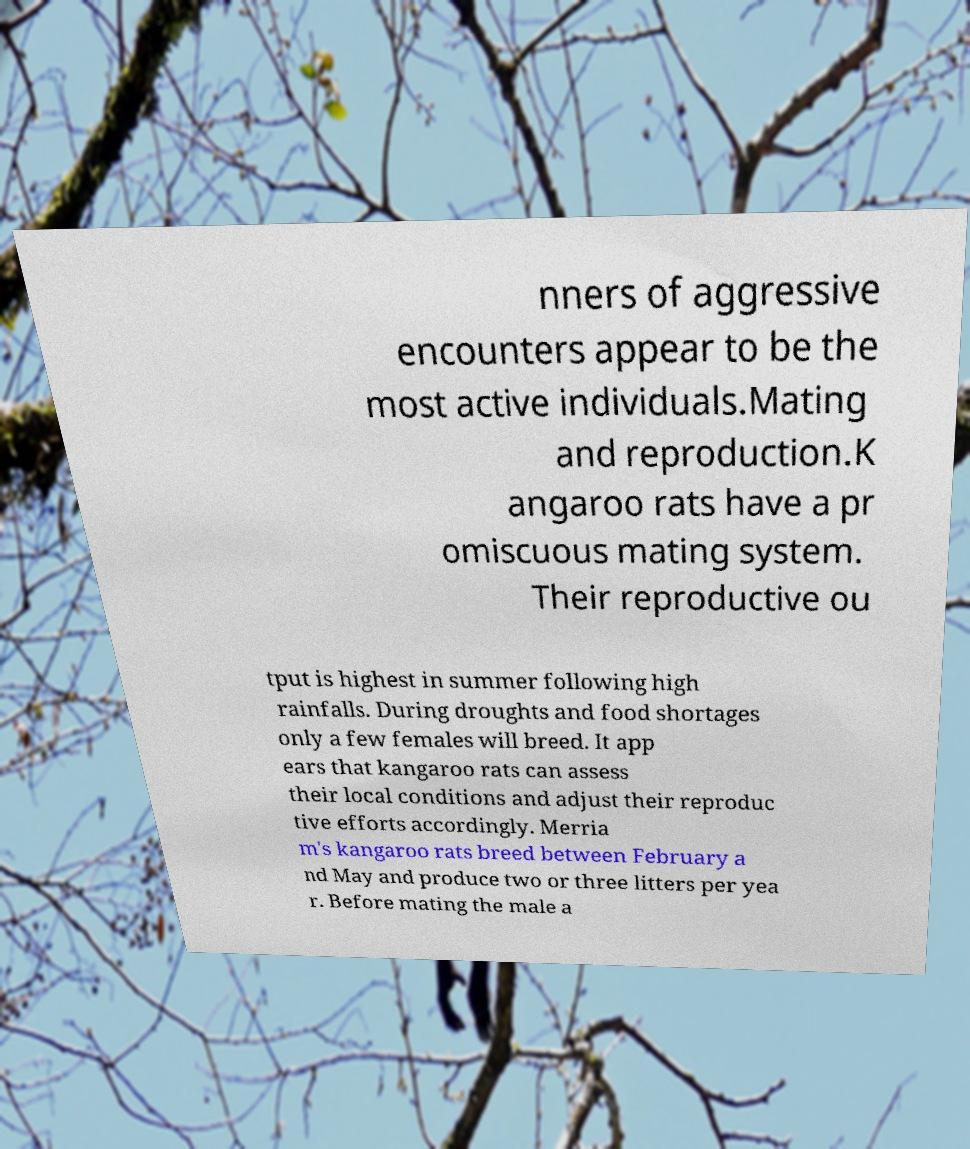Can you read and provide the text displayed in the image?This photo seems to have some interesting text. Can you extract and type it out for me? nners of aggressive encounters appear to be the most active individuals.Mating and reproduction.K angaroo rats have a pr omiscuous mating system. Their reproductive ou tput is highest in summer following high rainfalls. During droughts and food shortages only a few females will breed. It app ears that kangaroo rats can assess their local conditions and adjust their reproduc tive efforts accordingly. Merria m's kangaroo rats breed between February a nd May and produce two or three litters per yea r. Before mating the male a 